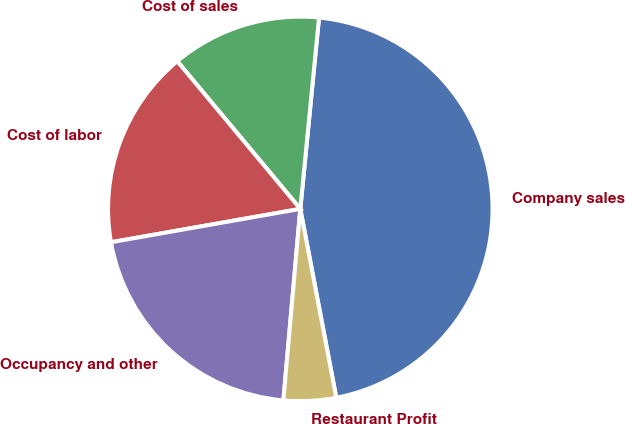Convert chart. <chart><loc_0><loc_0><loc_500><loc_500><pie_chart><fcel>Company sales<fcel>Cost of sales<fcel>Cost of labor<fcel>Occupancy and other<fcel>Restaurant Profit<nl><fcel>45.45%<fcel>12.61%<fcel>16.72%<fcel>20.82%<fcel>4.4%<nl></chart> 